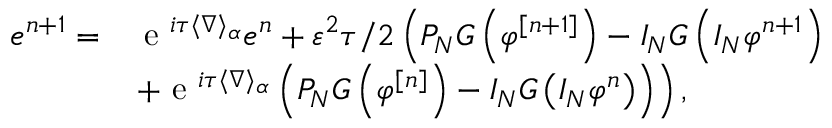<formula> <loc_0><loc_0><loc_500><loc_500>\begin{array} { r l } { e ^ { n + 1 } = } & { e ^ { i \tau \langle \nabla \rangle _ { \alpha } } e ^ { n } + \varepsilon ^ { 2 } \tau / 2 \left ( P _ { N } G \left ( \varphi ^ { [ n + 1 ] } \right ) - I _ { N } G \left ( I _ { N } \varphi ^ { n + 1 } \right ) } \\ & { + e ^ { i \tau \langle \nabla \rangle _ { \alpha } } \left ( P _ { N } G \left ( \varphi ^ { [ n ] } \right ) - I _ { N } G \left ( I _ { N } \varphi ^ { n } \right ) \right ) \right ) , } \end{array}</formula> 